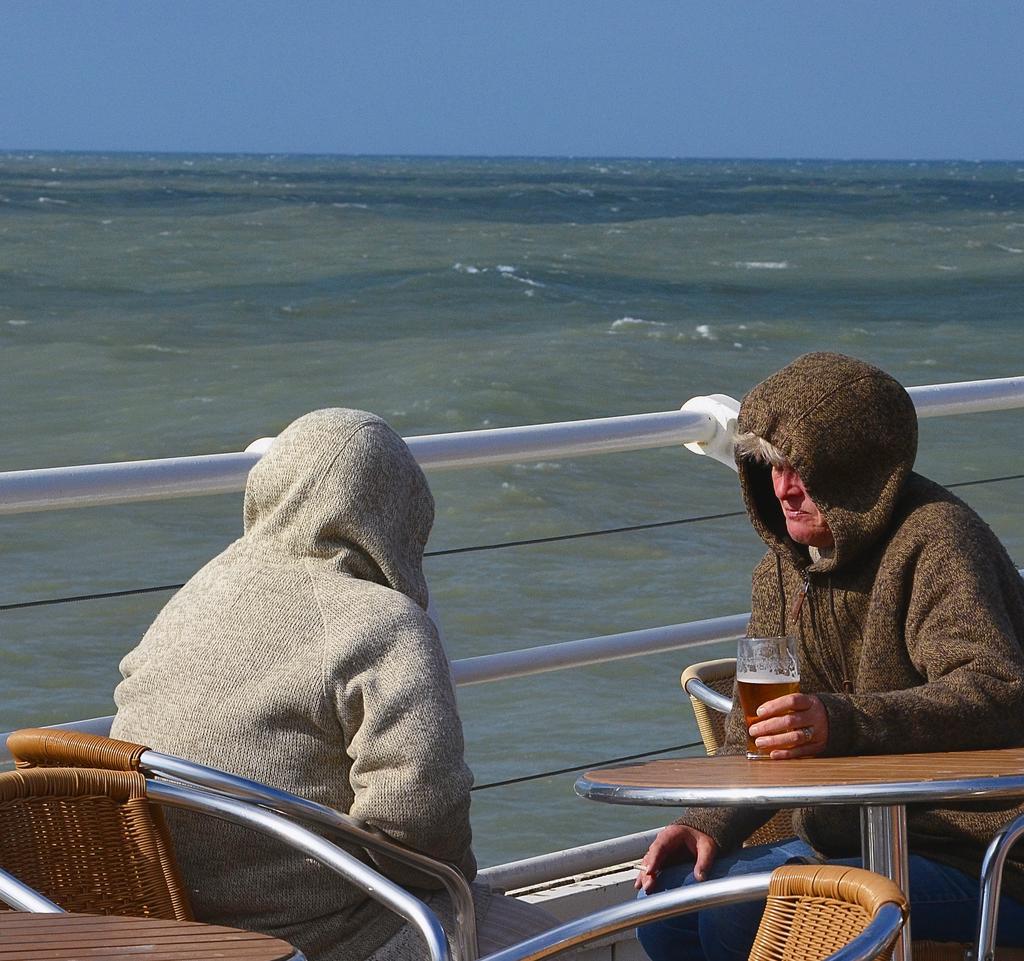In one or two sentences, can you explain what this image depicts? There is a person in gray color coat sitting on a chair in front of other person who is in brown color coat and is sitting on other chair, placing hand on the table and holding a glass which is filled with drink. On the left side, there are chairs arranged in a table. In the background, there is a white color fencing, there is an ocean and there is sky. 